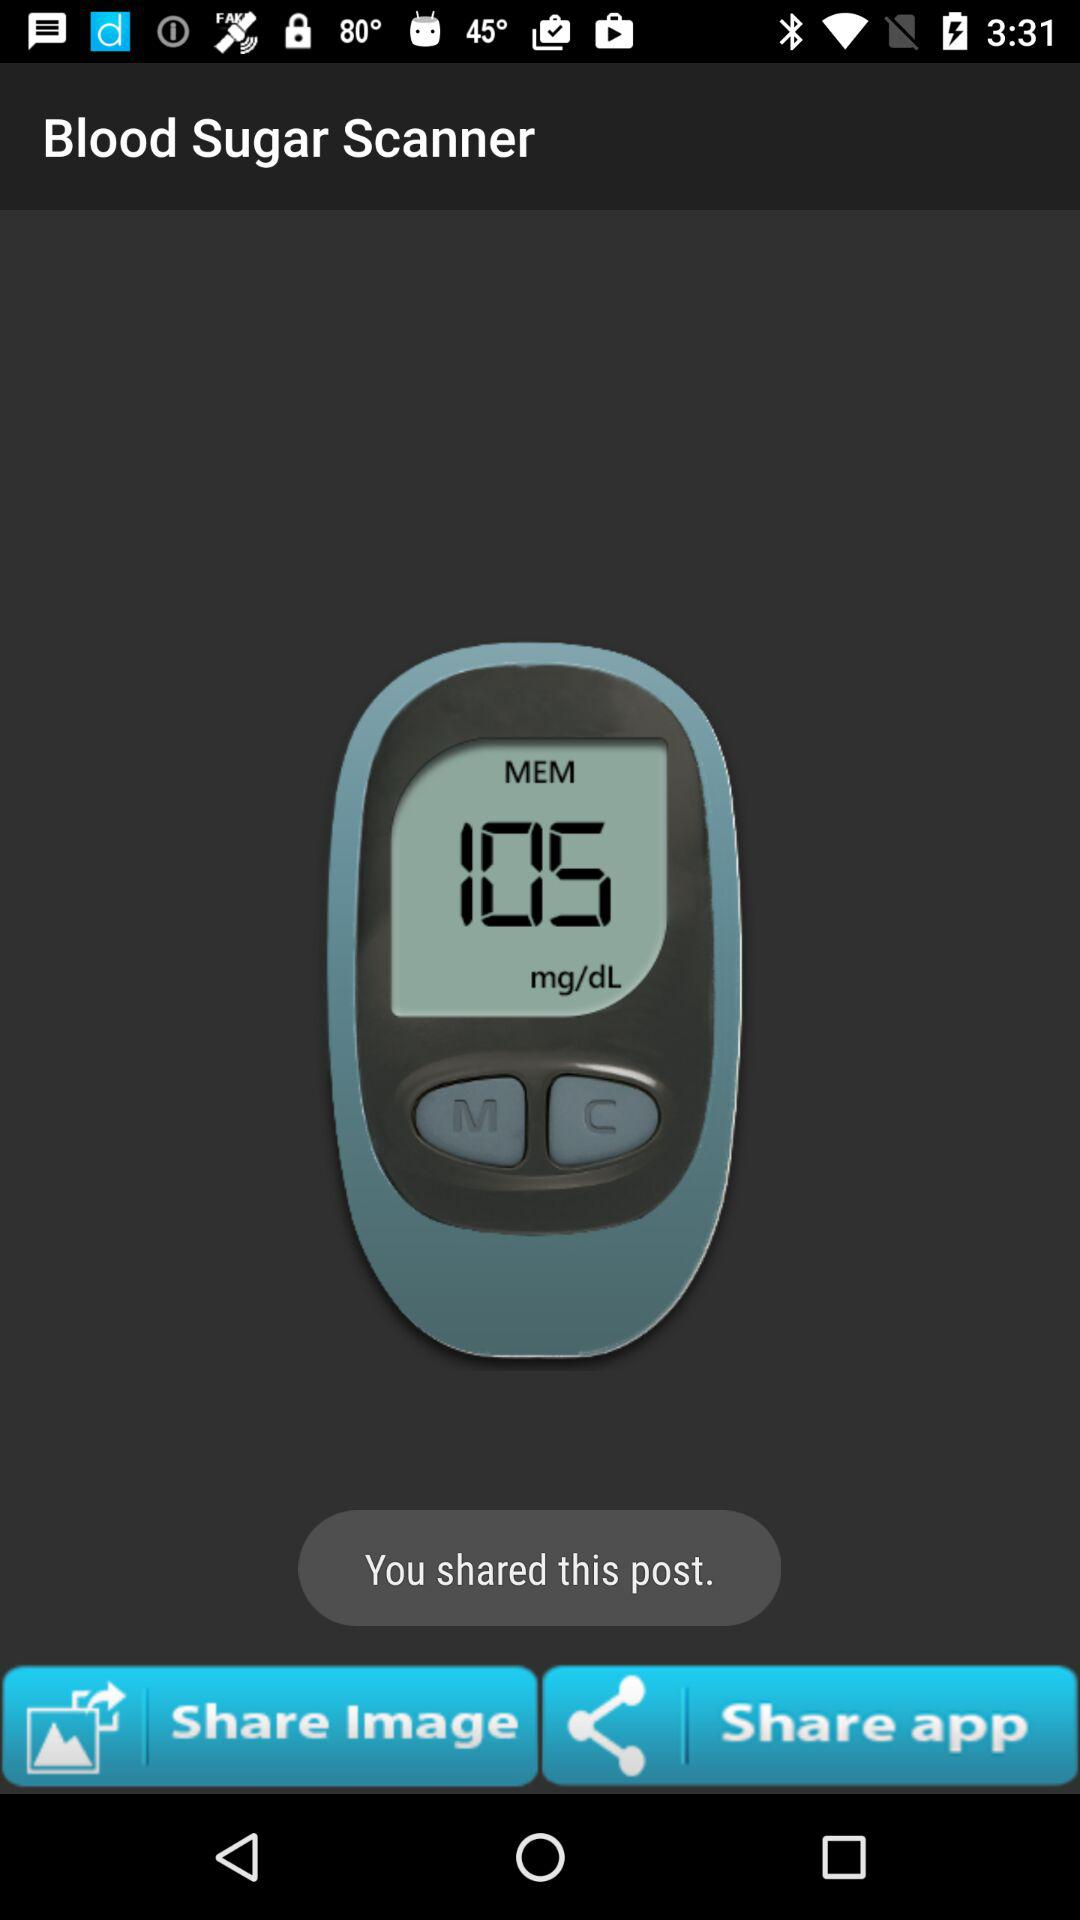What is the name of the application? The name of the application is "Blood Sugar Scanner". 